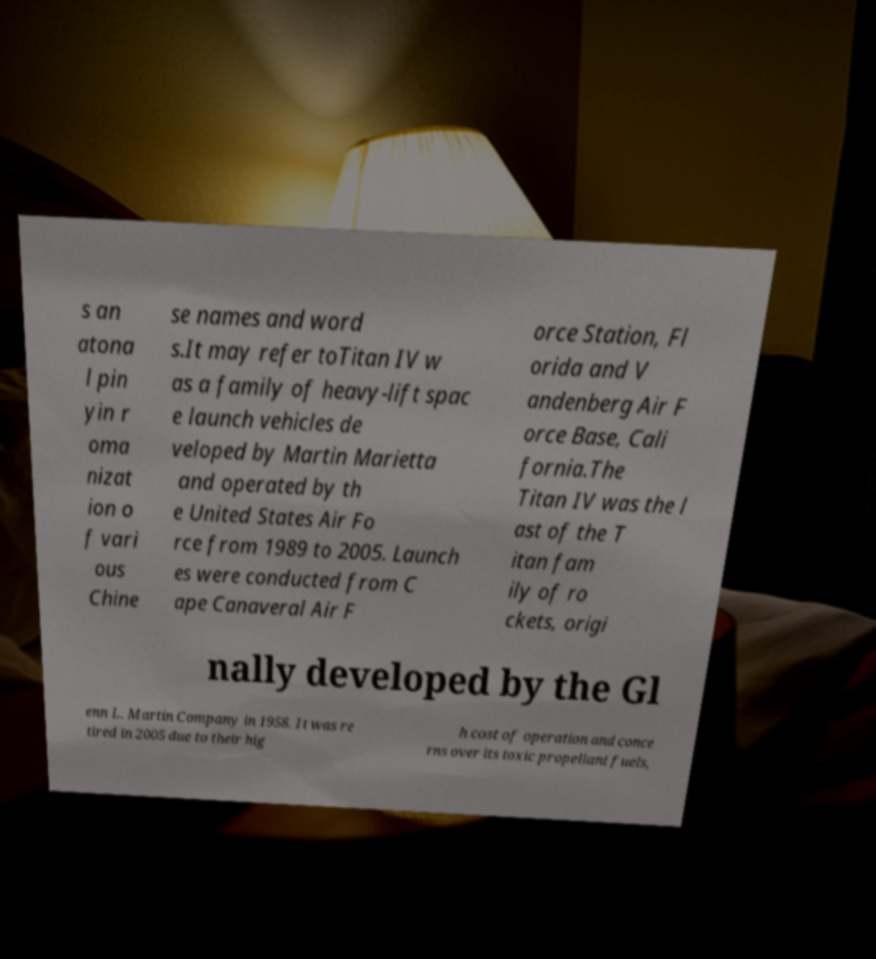What messages or text are displayed in this image? I need them in a readable, typed format. s an atona l pin yin r oma nizat ion o f vari ous Chine se names and word s.It may refer toTitan IV w as a family of heavy-lift spac e launch vehicles de veloped by Martin Marietta and operated by th e United States Air Fo rce from 1989 to 2005. Launch es were conducted from C ape Canaveral Air F orce Station, Fl orida and V andenberg Air F orce Base, Cali fornia.The Titan IV was the l ast of the T itan fam ily of ro ckets, origi nally developed by the Gl enn L. Martin Company in 1958. It was re tired in 2005 due to their hig h cost of operation and conce rns over its toxic propellant fuels, 